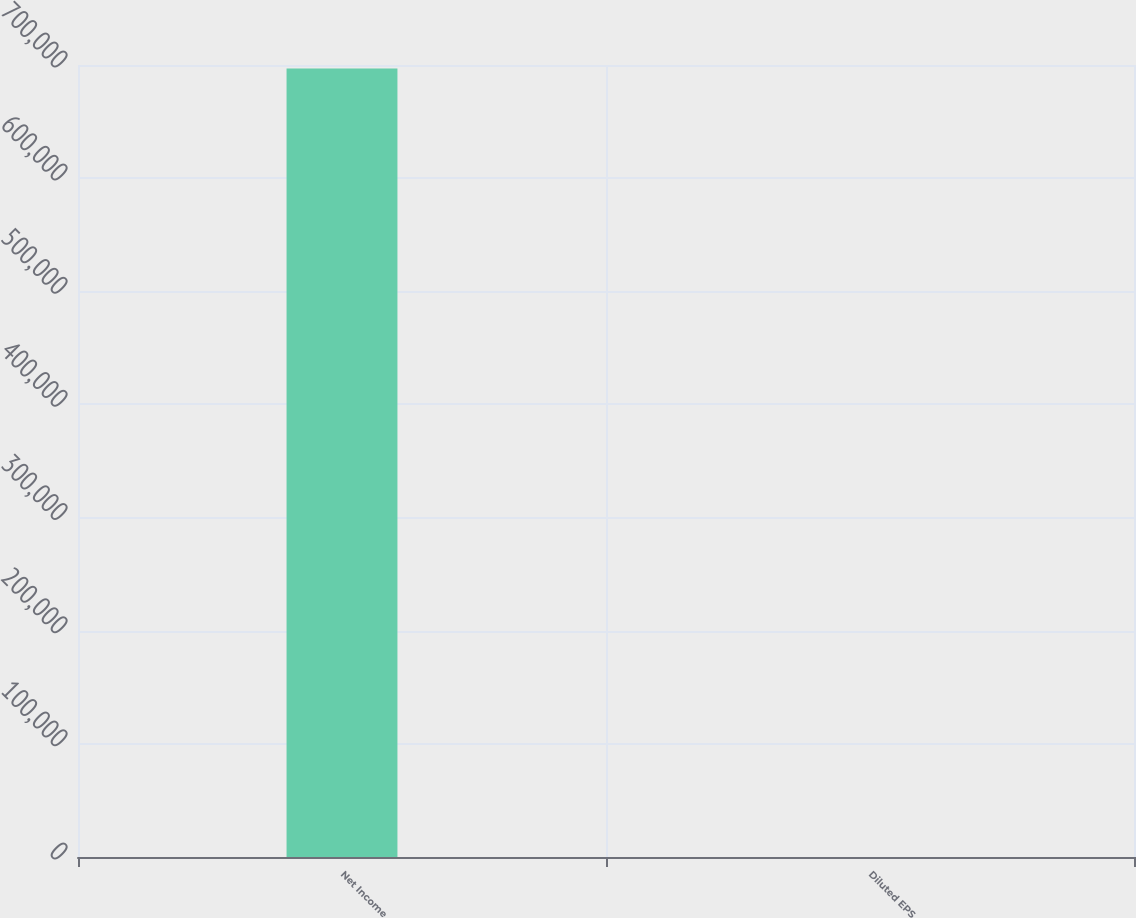Convert chart. <chart><loc_0><loc_0><loc_500><loc_500><bar_chart><fcel>Net Income<fcel>Diluted EPS<nl><fcel>696878<fcel>2.2<nl></chart> 